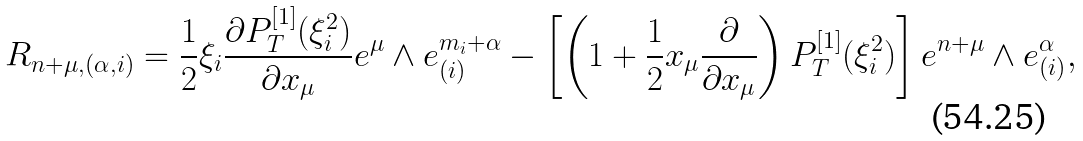<formula> <loc_0><loc_0><loc_500><loc_500>R _ { n + \mu , ( \alpha , i ) } = \frac { 1 } { 2 } \xi _ { i } \frac { \partial P _ { T } ^ { [ 1 ] } ( \xi _ { i } ^ { 2 } ) } { \partial x _ { \mu } } e ^ { \mu } \wedge e ^ { m _ { i } + \alpha } _ { ( i ) } - \left [ \left ( 1 + \frac { 1 } { 2 } x _ { \mu } \frac { \partial } { \partial x _ { \mu } } \right ) P _ { T } ^ { [ 1 ] } ( \xi _ { i } ^ { 2 } ) \right ] e ^ { n + \mu } \wedge e ^ { \alpha } _ { ( i ) } ,</formula> 